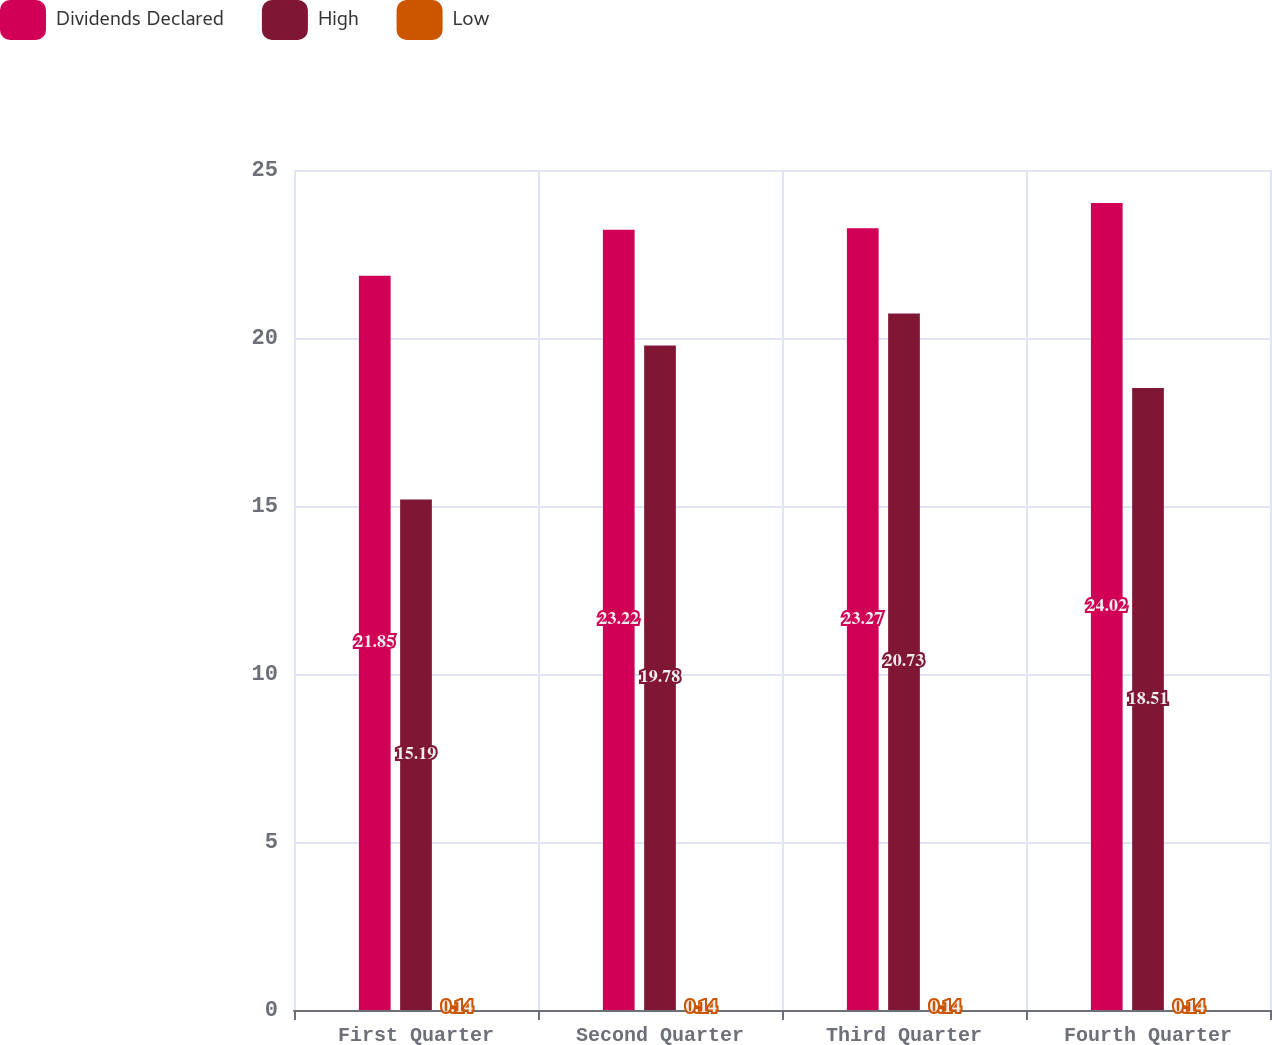Convert chart to OTSL. <chart><loc_0><loc_0><loc_500><loc_500><stacked_bar_chart><ecel><fcel>First Quarter<fcel>Second Quarter<fcel>Third Quarter<fcel>Fourth Quarter<nl><fcel>Dividends Declared<fcel>21.85<fcel>23.22<fcel>23.27<fcel>24.02<nl><fcel>High<fcel>15.19<fcel>19.78<fcel>20.73<fcel>18.51<nl><fcel>Low<fcel>0.14<fcel>0.14<fcel>0.14<fcel>0.14<nl></chart> 